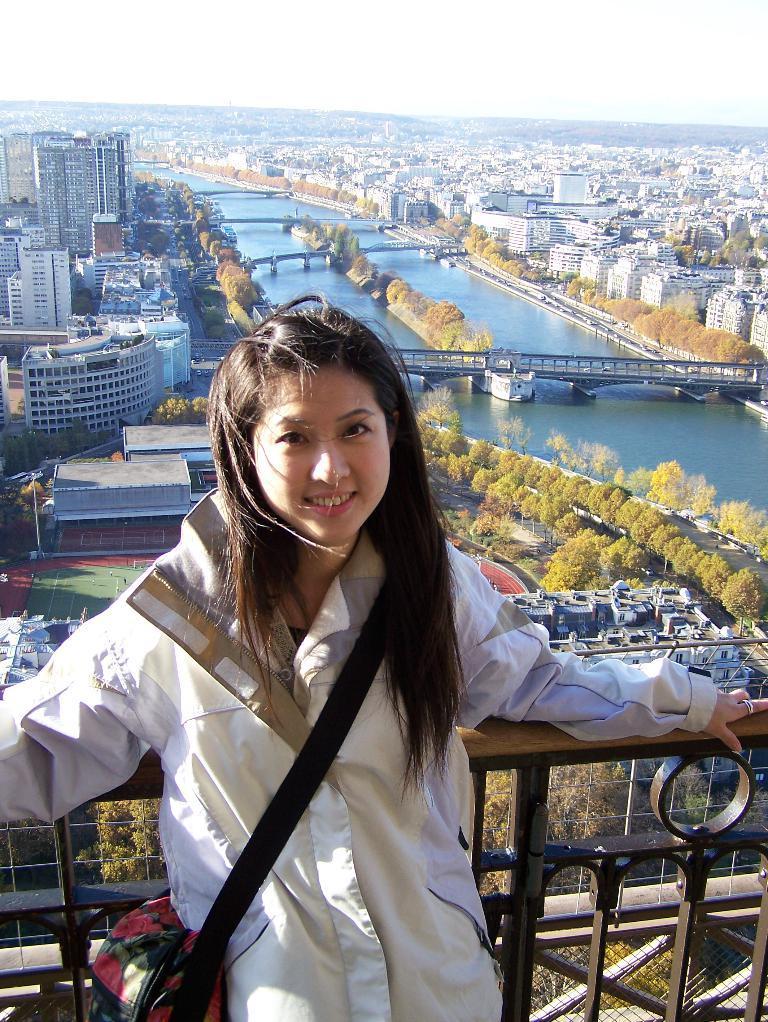Could you give a brief overview of what you see in this image? In this image there is a woman leaning on a railing, in the background there are buildings, trees, lake, bridges and the sky. 